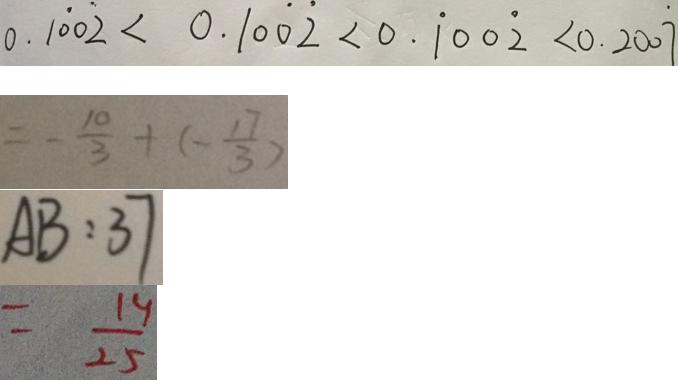<formula> <loc_0><loc_0><loc_500><loc_500>0 . 1 \dot { 0 } 0 \dot { 2 } < 0 . 1 0 \dot { 0 } \dot { 2 } < 0 . \dot { 1 } 0 0 \dot { 2 } < 0 . 2 0 0 \dot { 7 } 
 = - \frac { 1 0 } { 3 } + ( - \frac { 1 7 } { 3 } ) 
 A B : 3 7 
 = \frac { 1 4 } { 2 5 }</formula> 